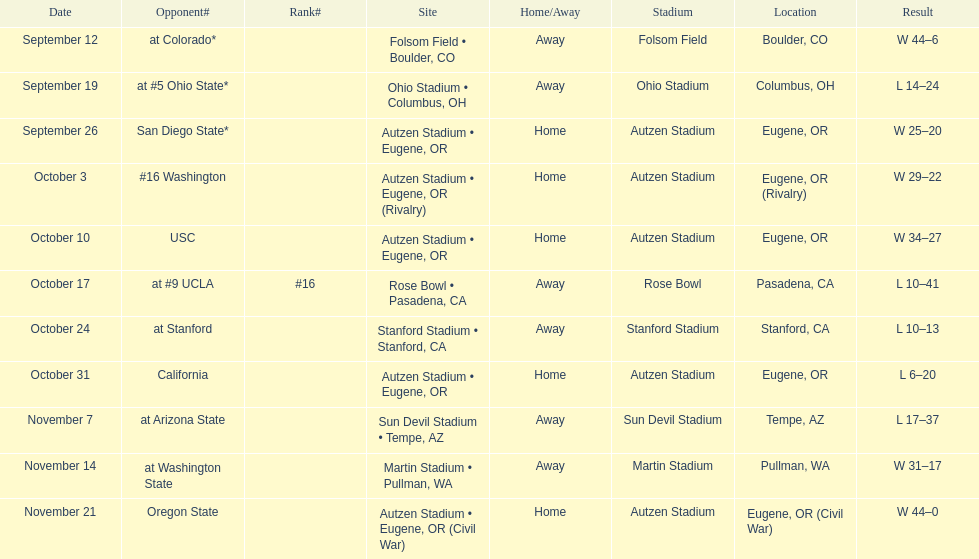Did the team win or lose more games? Win. Can you give me this table as a dict? {'header': ['Date', 'Opponent#', 'Rank#', 'Site', 'Home/Away', 'Stadium', 'Location', 'Result'], 'rows': [['September 12', 'at\xa0Colorado*', '', 'Folsom Field • Boulder, CO', 'Away', 'Folsom Field', 'Boulder, CO', 'W\xa044–6'], ['September 19', 'at\xa0#5\xa0Ohio State*', '', 'Ohio Stadium • Columbus, OH', 'Away', 'Ohio Stadium', 'Columbus, OH', 'L\xa014–24'], ['September 26', 'San Diego State*', '', 'Autzen Stadium • Eugene, OR', 'Home', 'Autzen Stadium', 'Eugene, OR', 'W\xa025–20'], ['October 3', '#16\xa0Washington', '', 'Autzen Stadium • Eugene, OR (Rivalry)', 'Home', 'Autzen Stadium', 'Eugene, OR (Rivalry)', 'W\xa029–22'], ['October 10', 'USC', '', 'Autzen Stadium • Eugene, OR', 'Home', 'Autzen Stadium', 'Eugene, OR', 'W\xa034–27'], ['October 17', 'at\xa0#9\xa0UCLA', '#16', 'Rose Bowl • Pasadena, CA', 'Away', 'Rose Bowl', 'Pasadena, CA', 'L\xa010–41'], ['October 24', 'at\xa0Stanford', '', 'Stanford Stadium • Stanford, CA', 'Away', 'Stanford Stadium', 'Stanford, CA', 'L\xa010–13'], ['October 31', 'California', '', 'Autzen Stadium • Eugene, OR', 'Home', 'Autzen Stadium', 'Eugene, OR', 'L\xa06–20'], ['November 7', 'at\xa0Arizona State', '', 'Sun Devil Stadium • Tempe, AZ', 'Away', 'Sun Devil Stadium', 'Tempe, AZ', 'L\xa017–37'], ['November 14', 'at\xa0Washington State', '', 'Martin Stadium • Pullman, WA', 'Away', 'Martin Stadium', 'Pullman, WA', 'W\xa031–17'], ['November 21', 'Oregon State', '', 'Autzen Stadium • Eugene, OR (Civil War)', 'Home', 'Autzen Stadium', 'Eugene, OR (Civil War)', 'W\xa044–0']]} 